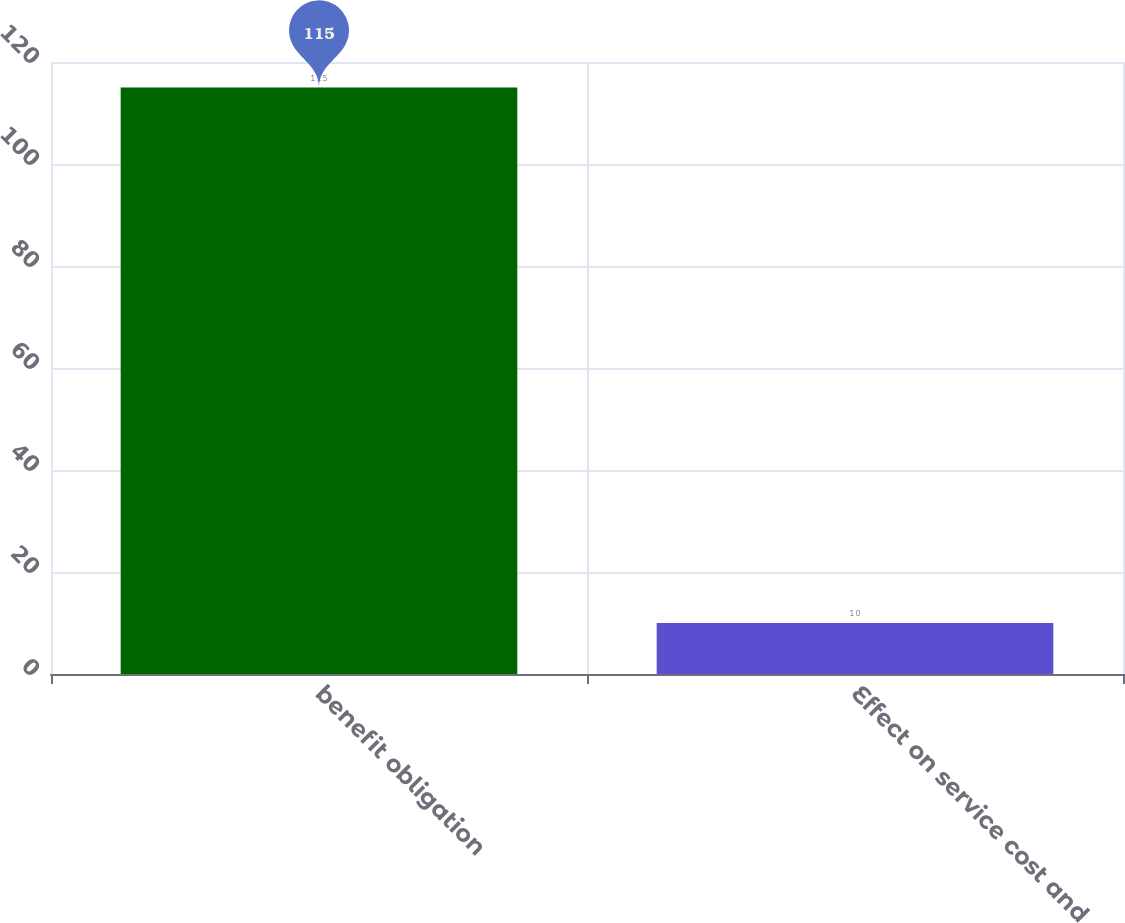<chart> <loc_0><loc_0><loc_500><loc_500><bar_chart><fcel>benefit obligation<fcel>Effect on service cost and<nl><fcel>115<fcel>10<nl></chart> 